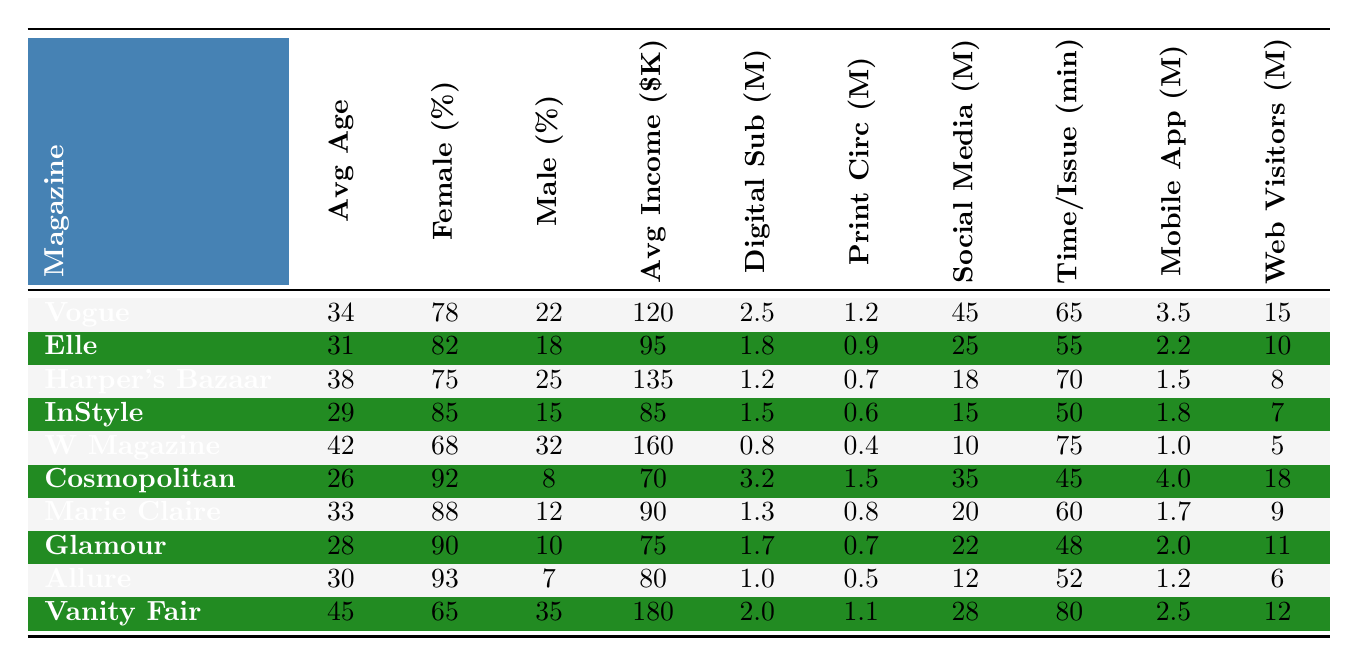What is the average age of readers for Vogue? Looking at the column for "Average Age," Vogue has a value of 34.
Answer: 34 Which magazine has the highest percentage of female readership? By comparing the "Female Readership (%)" values, Allure has the highest at 93%.
Answer: 93% What is the difference in digital subscribers between Cosmopolitan and W Magazine? Cosmopolitan has 3.2 million digital subscribers, and W Magazine has 0.8 million. The difference is 3.2 - 0.8 = 2.4 million.
Answer: 2.4 million Is the average household income for Vanity Fair higher than that of Vogue? Vanity Fair's average income is 180K, while Vogue's is 120K. Since 180 > 120, the statement is true.
Answer: Yes Which magazine has the highest average time spent per issue? Reviewing the "Average Time Spent per Issue (Minutes)" column, Vanity Fair has the highest at 80 minutes.
Answer: 80 minutes What is the total number of mobile app users across all magazines? To find the total, sum the "Mobile App Users (Millions)" values: 3.5 + 2.2 + 1.5 + 1.8 + 1.0 + 4.0 + 1.7 + 2.0 + 1.2 + 2.5 = 20.4 million.
Answer: 20.4 million Which magazine has the lowest print circulation? The "Print Circulation (Millions)" column shows that W Magazine has the lowest at 0.4 million.
Answer: 0.4 million What is the average female readership percentage across all magazines? Add up all the "Female Readership (%)" values (78 + 82 + 75 + 85 + 68 + 92 + 88 + 90 + 93 + 65 =  918) and divide by 10 (the number of magazines) to get 91.8%.
Answer: 91.8% How many magazines have a male readership percentage below 20%? Looking at the "Male Readership (%)" values, only Cosmopolitan (8%) and InStyle (15%) have values below 20%, which is 2 magazines.
Answer: 2 magazines Is the average household income for magazines with over 2 million digital subscribers generally higher than those with less? The magazines with over 2 million digital subscribers are Vogue, Cosmopolitan, and Vanity Fair (averaging $130K), while those with less (Elle, Harper's Bazaar, InStyle, W Magazine, Marie Claire, Glamour, and Allure) average $83K. So yes.
Answer: Yes 